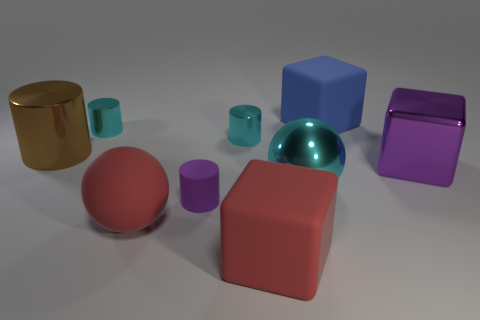Add 1 tiny brown shiny balls. How many objects exist? 10 Subtract all spheres. How many objects are left? 7 Subtract all blue spheres. Subtract all purple cubes. How many objects are left? 8 Add 6 cyan cylinders. How many cyan cylinders are left? 8 Add 1 purple metal cubes. How many purple metal cubes exist? 2 Subtract 1 red cubes. How many objects are left? 8 